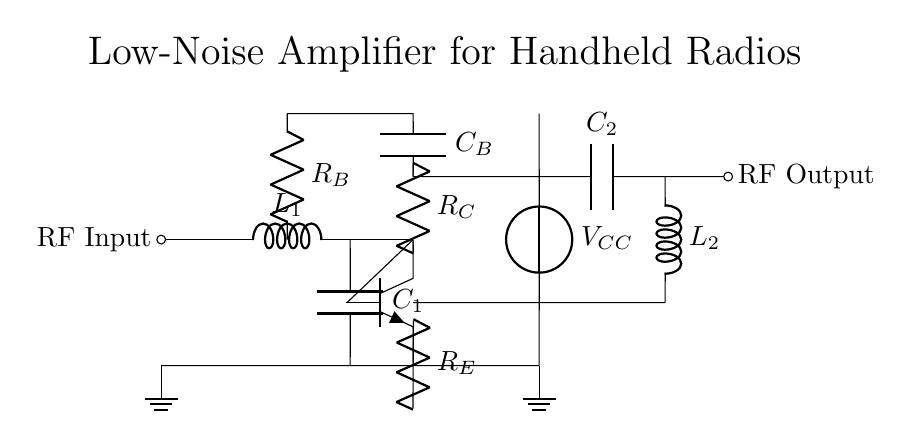What is the component connected to the RF Input? The component connected to the RF Input is an inductor labeled L1, which is part of the matching network. It is positioned right after the RF Input to help match the impedance.
Answer: L1 What does R_E in the circuit diagram represent? R_E represents the emitter resistor in the transistor circuit, which is used to stabilize the operating point and improve linearity. It is connected to the emitter terminal of the transistor.
Answer: Emitter resistor What is the purpose of C_B in the circuit? C_B is a coupling capacitor that allows AC signals to pass while blocking DC. This capacitor connects the base of the transistor to the biasing network.
Answer: Coupling capacitor What is the importance of the matching network in this circuit? The matching network, consisting of L1 and C1, is crucial for ensuring maximum power transfer between the input and the transistor by matching the input impedance to the source impedance.
Answer: Maximum power transfer What is the voltage source used in this circuit? The voltage source used is labeled V_CC, which provides the necessary collector voltage for the transistor to operate efficiently.
Answer: V_CC How many capacitors are present in the circuit? There are two capacitors present in the circuit, which are C1 and C2, each serving different roles in the amplifier function.
Answer: Two 